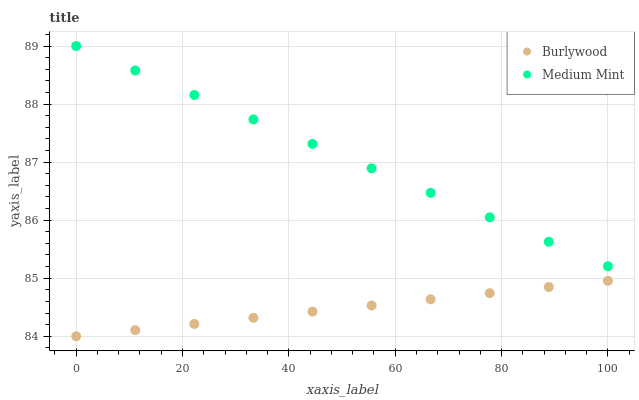Does Burlywood have the minimum area under the curve?
Answer yes or no. Yes. Does Medium Mint have the maximum area under the curve?
Answer yes or no. Yes. Does Medium Mint have the minimum area under the curve?
Answer yes or no. No. Is Burlywood the smoothest?
Answer yes or no. Yes. Is Medium Mint the roughest?
Answer yes or no. Yes. Is Medium Mint the smoothest?
Answer yes or no. No. Does Burlywood have the lowest value?
Answer yes or no. Yes. Does Medium Mint have the lowest value?
Answer yes or no. No. Does Medium Mint have the highest value?
Answer yes or no. Yes. Is Burlywood less than Medium Mint?
Answer yes or no. Yes. Is Medium Mint greater than Burlywood?
Answer yes or no. Yes. Does Burlywood intersect Medium Mint?
Answer yes or no. No. 